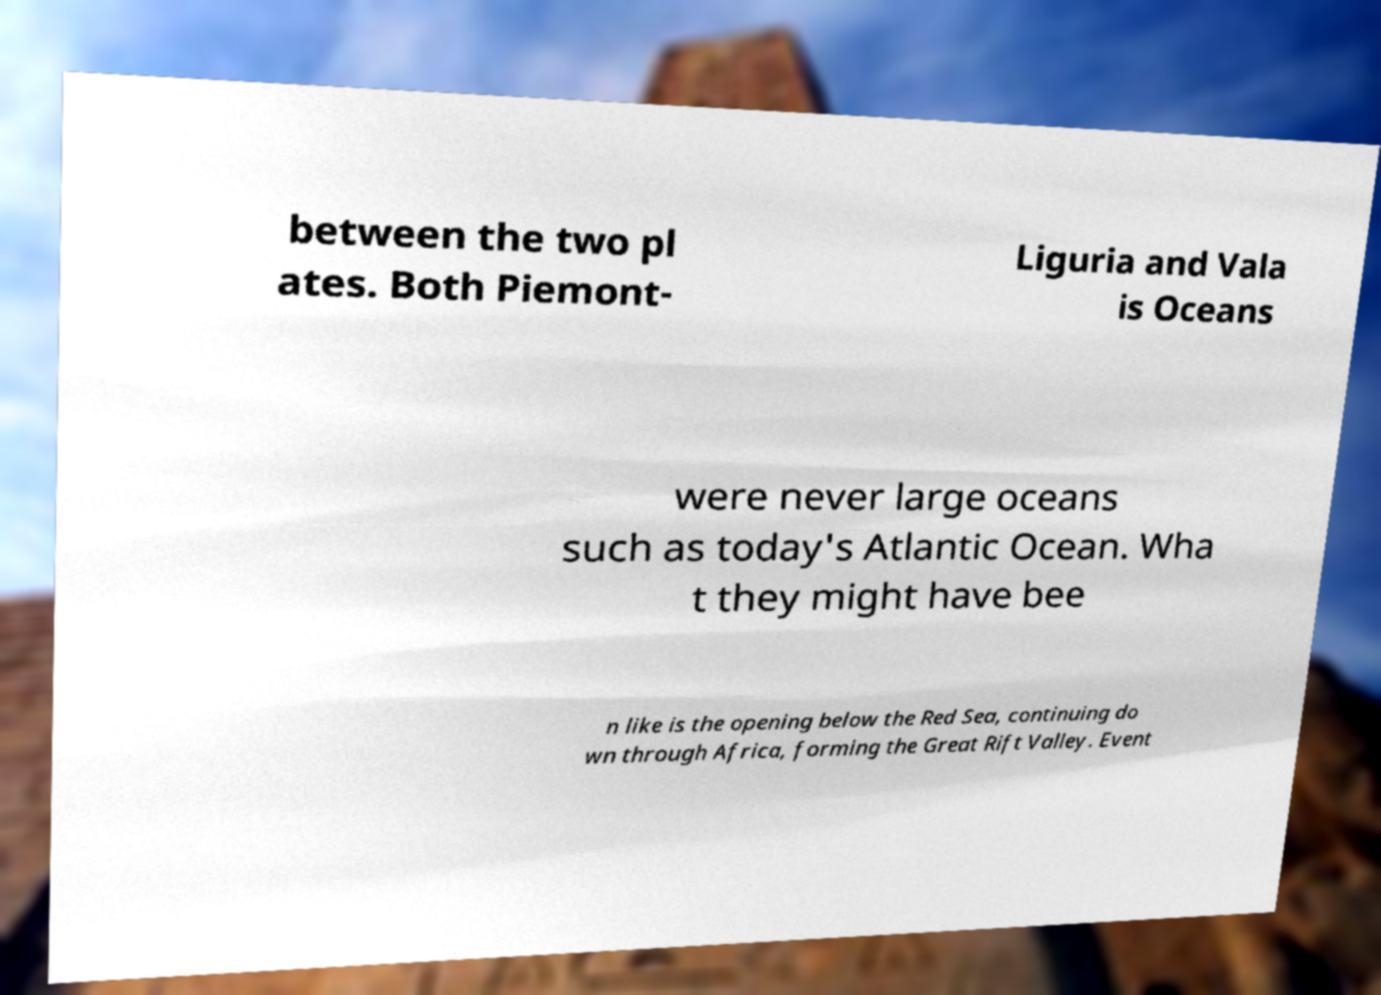Can you accurately transcribe the text from the provided image for me? between the two pl ates. Both Piemont- Liguria and Vala is Oceans were never large oceans such as today's Atlantic Ocean. Wha t they might have bee n like is the opening below the Red Sea, continuing do wn through Africa, forming the Great Rift Valley. Event 